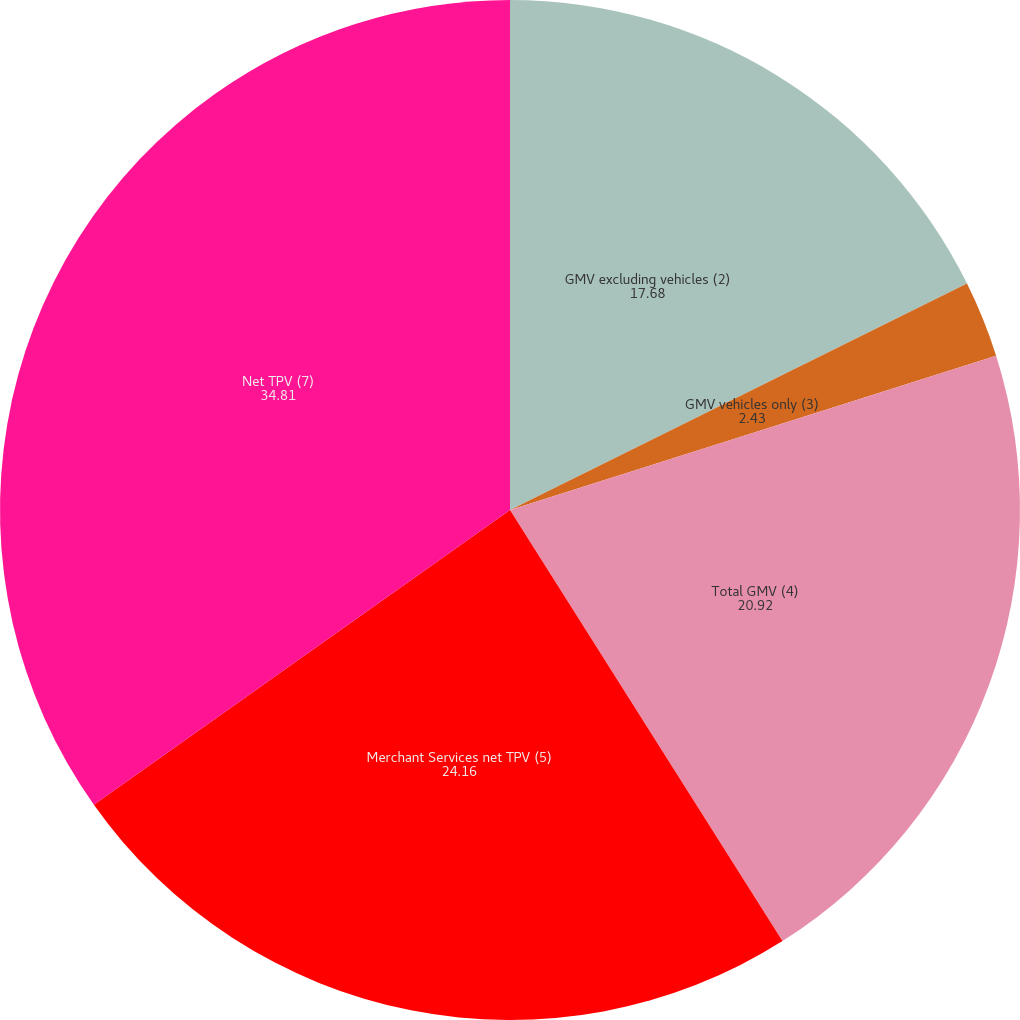<chart> <loc_0><loc_0><loc_500><loc_500><pie_chart><fcel>GMV excluding vehicles (2)<fcel>GMV vehicles only (3)<fcel>Total GMV (4)<fcel>Merchant Services net TPV (5)<fcel>Net TPV (7)<nl><fcel>17.68%<fcel>2.43%<fcel>20.92%<fcel>24.16%<fcel>34.81%<nl></chart> 